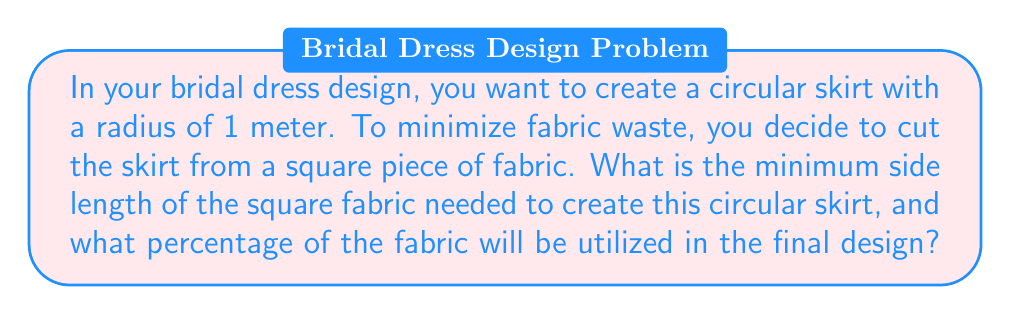Help me with this question. To solve this problem, we need to follow these steps:

1. Determine the minimum square that can contain a circle of radius 1 meter.
2. Calculate the area of the square and the circle.
3. Compute the percentage of fabric utilized.

Step 1: Minimum square size

The diameter of the circle is 2 meters. To fit this circle within a square, the side length of the square must be equal to the diameter. Therefore, the minimum side length of the square fabric is 2 meters.

Step 2: Area calculations

Area of the square:
$$A_{square} = s^2 = 2^2 = 4 \text{ m}^2$$

Area of the circular skirt:
$$A_{circle} = \pi r^2 = \pi (1)^2 = \pi \text{ m}^2$$

Step 3: Percentage of fabric utilized

To calculate the percentage of fabric utilized, we divide the area of the circle by the area of the square and multiply by 100:

$$\text{Utilization} = \frac{A_{circle}}{A_{square}} \times 100\% = \frac{\pi}{4} \times 100\%$$

$$\text{Utilization} = \frac{3.14159...}{4} \times 100\% \approx 78.54\%$$

[asy]
unitsize(50);
fill((-1,-1)--(1,-1)--(1,1)--(-1,1)--cycle, gray(0.8));
fill(circle((0,0), 1), white);
draw((-1,-1)--(1,-1)--(1,1)--(-1,1)--cycle);
draw(circle((0,0), 1));
label("2 m", (0,-1.1), S);
label("Unused", (0.7,0.7), NE);
label("Used", (0,-0.5), S);
[/asy]
Answer: The minimum side length of the square fabric needed is 2 meters, and approximately 78.54% of the fabric will be utilized in the final circular skirt design. 